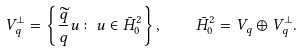Convert formula to latex. <formula><loc_0><loc_0><loc_500><loc_500>V _ { q } ^ { \perp } = \left \{ \frac { \widetilde { q } } { q } u \colon u \in \bar { H } _ { 0 } ^ { 2 } \right \} , \quad \bar { H } _ { 0 } ^ { 2 } = V _ { q } \oplus V _ { q } ^ { \perp } .</formula> 